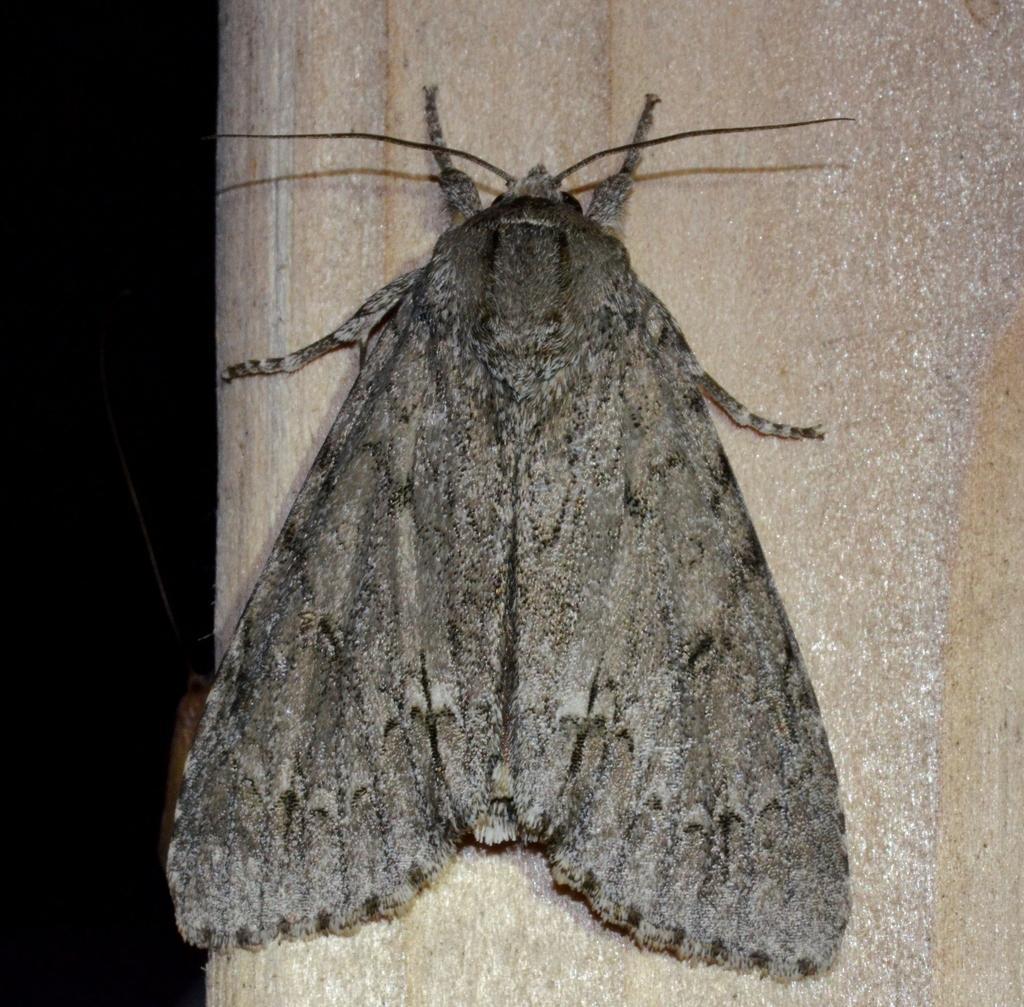In one or two sentences, can you explain what this image depicts? In this image in the center there is an insect on the wall, and in the background there are some objects. 